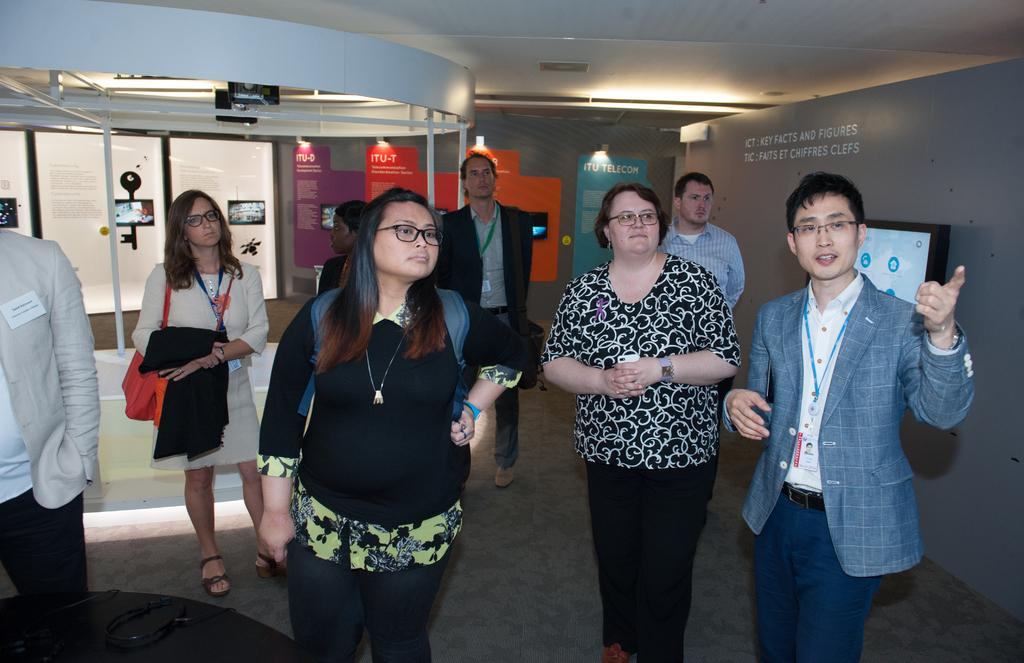What is happening in the image? There are people standing in the image. What can be seen on the right side of the image? There is a screen on the wall on the right side of the image. What is on the wall in the background of the image? There are boards pasted on the wall in the background of the image. What can be seen illuminating the area in the image? There are lights visible in the image. What type of bait is being used by the people in the image? There is no bait present in the image; it features people standing and various objects on the walls. What word is written on the screen in the image? The image does not show any specific word on the screen; it only shows that there is a screen on the wall. 